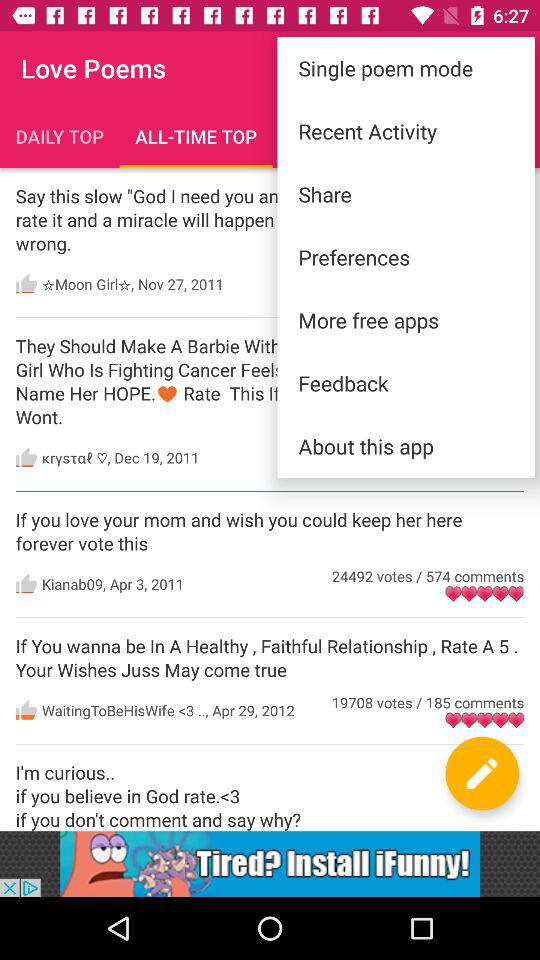Which tab is selected? The selected tab is "ALL-TIME TOP". 